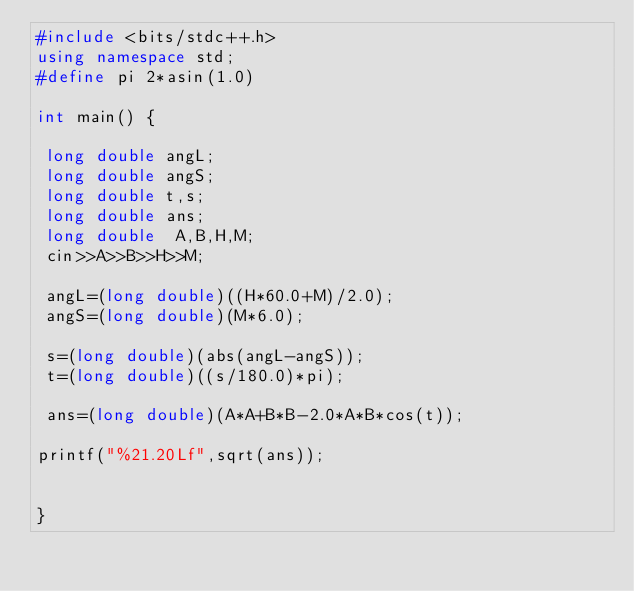<code> <loc_0><loc_0><loc_500><loc_500><_C++_>#include <bits/stdc++.h>
using namespace std;
#define pi 2*asin(1.0)
 
int main() {

 long double angL;
 long double angS;
 long double t,s;
 long double ans;
 long double  A,B,H,M;
 cin>>A>>B>>H>>M;

 angL=(long double)((H*60.0+M)/2.0);
 angS=(long double)(M*6.0);

 s=(long double)(abs(angL-angS));
 t=(long double)((s/180.0)*pi);

 ans=(long double)(A*A+B*B-2.0*A*B*cos(t));

printf("%21.20Lf",sqrt(ans));


}</code> 